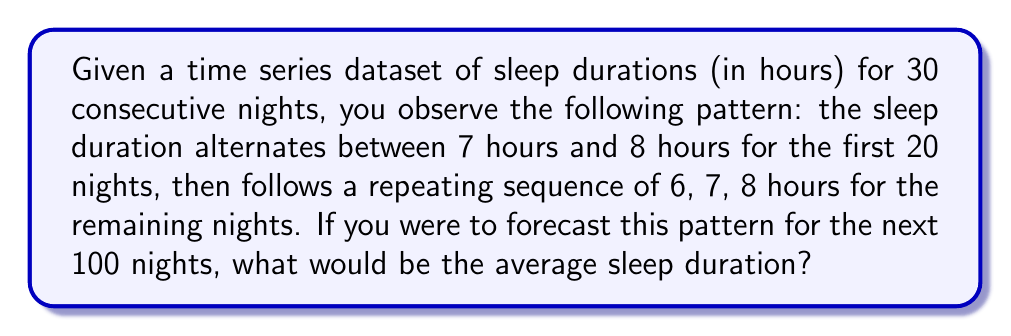Teach me how to tackle this problem. Let's approach this step-by-step:

1) First, let's analyze the pattern:
   - For the first 20 nights: 7, 8, 7, 8, 7, 8, ... (10 pairs of 7 and 8)
   - For the remaining 10 nights: 6, 7, 8, 6, 7, 8, 6, 7, 8, 6

2) Now, let's extend this to 100 nights:
   - The pattern of 6, 7, 8 repeats every 3 nights
   - In 100 nights, this pattern will repeat 33 times fully, with 1 night remaining

3) Let's calculate the total sleep hours:
   - In each full repetition: $6 + 7 + 8 = 21$ hours
   - Total for 33 repetitions: $33 * 21 = 693$ hours
   - The remaining 1 night will be 6 hours (as the pattern restarts)
   - Total sleep hours: $693 + 6 = 699$ hours

4) To find the average, we divide the total hours by the number of nights:

   $$ \text{Average} = \frac{699}{100} = 6.99 \text{ hours} $$
Answer: 6.99 hours 